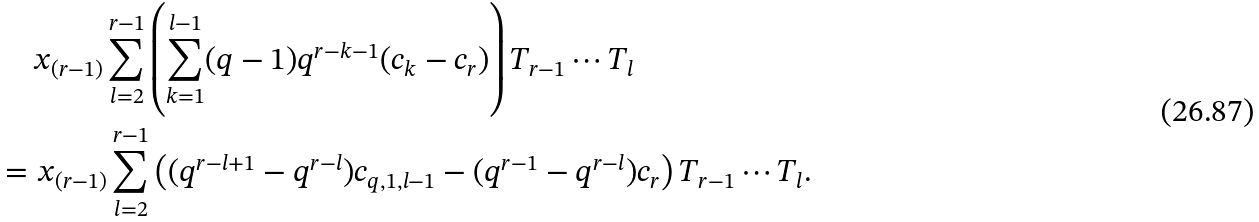<formula> <loc_0><loc_0><loc_500><loc_500>& \quad \, x _ { ( r - 1 ) } \sum ^ { r - 1 } _ { l = 2 } \left ( \sum ^ { l - 1 } _ { k = 1 } ( q - 1 ) q ^ { r - k - 1 } ( c _ { k } - c _ { r } ) \right ) T _ { r - 1 } \cdots T _ { l } \\ & = x _ { ( r - 1 ) } \sum ^ { r - 1 } _ { l = 2 } \left ( ( q ^ { r - l + 1 } - q ^ { r - l } ) c _ { q , 1 , l - 1 } - ( q ^ { r - 1 } - q ^ { r - l } ) c _ { r } \right ) T _ { r - 1 } \cdots T _ { l } .</formula> 